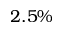Convert formula to latex. <formula><loc_0><loc_0><loc_500><loc_500>2 . 5 \%</formula> 